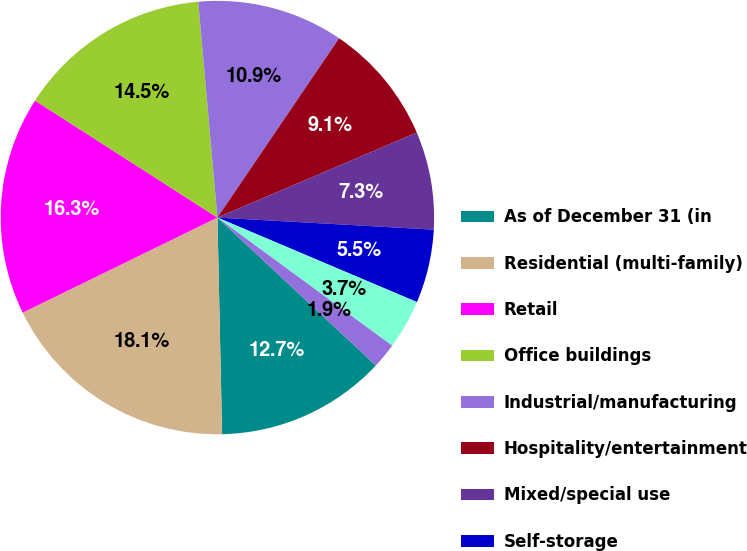Convert chart. <chart><loc_0><loc_0><loc_500><loc_500><pie_chart><fcel>As of December 31 (in<fcel>Residential (multi-family)<fcel>Retail<fcel>Office buildings<fcel>Industrial/manufacturing<fcel>Hospitality/entertainment<fcel>Mixed/special use<fcel>Self-storage<fcel>Health care<fcel>Land<nl><fcel>12.7%<fcel>18.11%<fcel>16.31%<fcel>14.51%<fcel>10.9%<fcel>9.1%<fcel>7.3%<fcel>5.49%<fcel>3.69%<fcel>1.89%<nl></chart> 